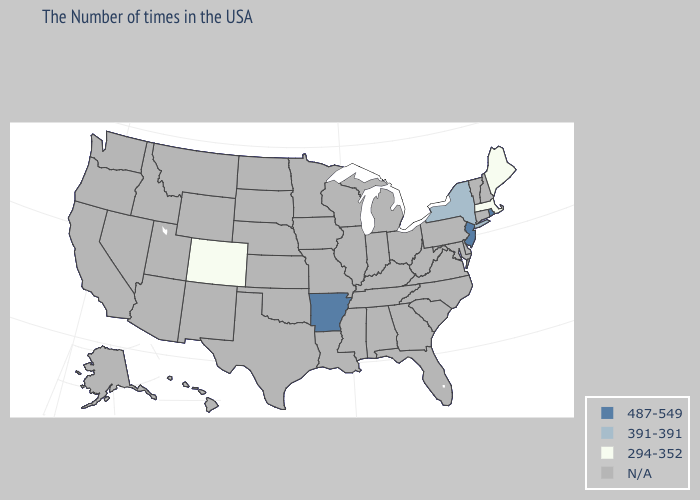Name the states that have a value in the range N/A?
Keep it brief. New Hampshire, Vermont, Connecticut, Delaware, Maryland, Pennsylvania, Virginia, North Carolina, South Carolina, West Virginia, Ohio, Florida, Georgia, Michigan, Kentucky, Indiana, Alabama, Tennessee, Wisconsin, Illinois, Mississippi, Louisiana, Missouri, Minnesota, Iowa, Kansas, Nebraska, Oklahoma, Texas, South Dakota, North Dakota, Wyoming, New Mexico, Utah, Montana, Arizona, Idaho, Nevada, California, Washington, Oregon, Alaska, Hawaii. Name the states that have a value in the range 487-549?
Keep it brief. Rhode Island, New Jersey, Arkansas. What is the value of Wyoming?
Keep it brief. N/A. Does New Jersey have the lowest value in the USA?
Quick response, please. No. What is the lowest value in the Northeast?
Answer briefly. 294-352. Among the states that border Connecticut , which have the lowest value?
Quick response, please. Massachusetts. Name the states that have a value in the range 487-549?
Be succinct. Rhode Island, New Jersey, Arkansas. Name the states that have a value in the range N/A?
Short answer required. New Hampshire, Vermont, Connecticut, Delaware, Maryland, Pennsylvania, Virginia, North Carolina, South Carolina, West Virginia, Ohio, Florida, Georgia, Michigan, Kentucky, Indiana, Alabama, Tennessee, Wisconsin, Illinois, Mississippi, Louisiana, Missouri, Minnesota, Iowa, Kansas, Nebraska, Oklahoma, Texas, South Dakota, North Dakota, Wyoming, New Mexico, Utah, Montana, Arizona, Idaho, Nevada, California, Washington, Oregon, Alaska, Hawaii. What is the lowest value in the South?
Be succinct. 487-549. Does Maine have the highest value in the USA?
Answer briefly. No. Name the states that have a value in the range 294-352?
Quick response, please. Maine, Massachusetts, Colorado. Does Colorado have the lowest value in the USA?
Keep it brief. Yes. Name the states that have a value in the range 487-549?
Give a very brief answer. Rhode Island, New Jersey, Arkansas. Which states have the lowest value in the South?
Concise answer only. Arkansas. 